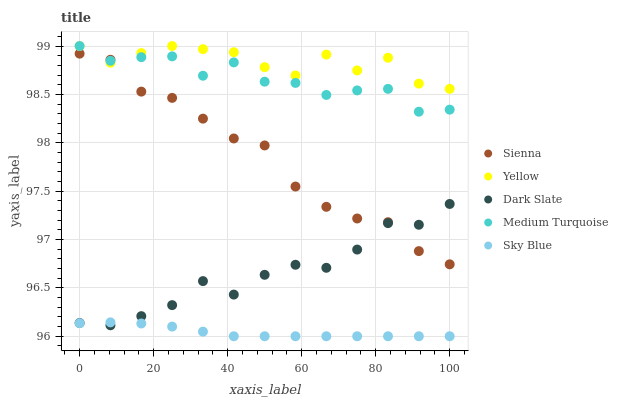Does Sky Blue have the minimum area under the curve?
Answer yes or no. Yes. Does Yellow have the maximum area under the curve?
Answer yes or no. Yes. Does Dark Slate have the minimum area under the curve?
Answer yes or no. No. Does Dark Slate have the maximum area under the curve?
Answer yes or no. No. Is Sky Blue the smoothest?
Answer yes or no. Yes. Is Yellow the roughest?
Answer yes or no. Yes. Is Dark Slate the smoothest?
Answer yes or no. No. Is Dark Slate the roughest?
Answer yes or no. No. Does Sky Blue have the lowest value?
Answer yes or no. Yes. Does Dark Slate have the lowest value?
Answer yes or no. No. Does Yellow have the highest value?
Answer yes or no. Yes. Does Dark Slate have the highest value?
Answer yes or no. No. Is Dark Slate less than Yellow?
Answer yes or no. Yes. Is Sienna greater than Sky Blue?
Answer yes or no. Yes. Does Sky Blue intersect Dark Slate?
Answer yes or no. Yes. Is Sky Blue less than Dark Slate?
Answer yes or no. No. Is Sky Blue greater than Dark Slate?
Answer yes or no. No. Does Dark Slate intersect Yellow?
Answer yes or no. No. 